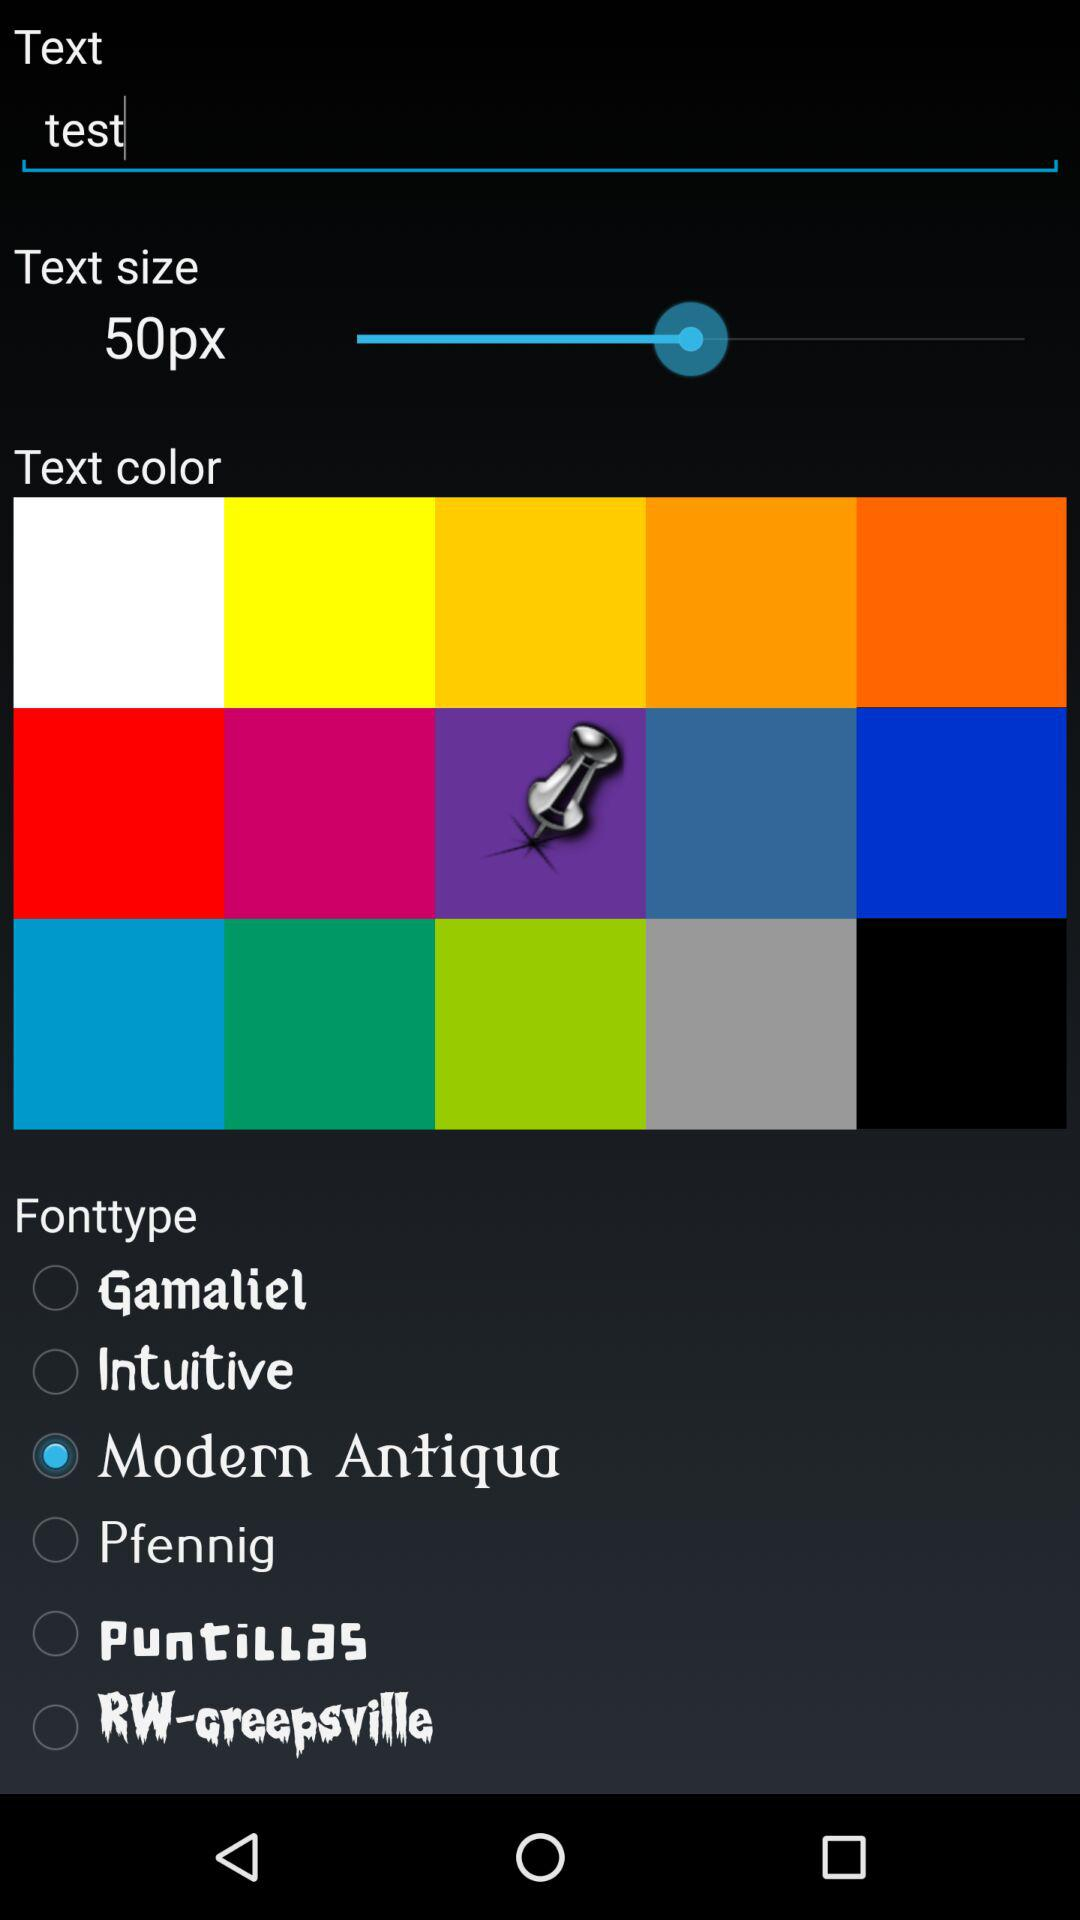What is the entered text? The entered text is "test". 